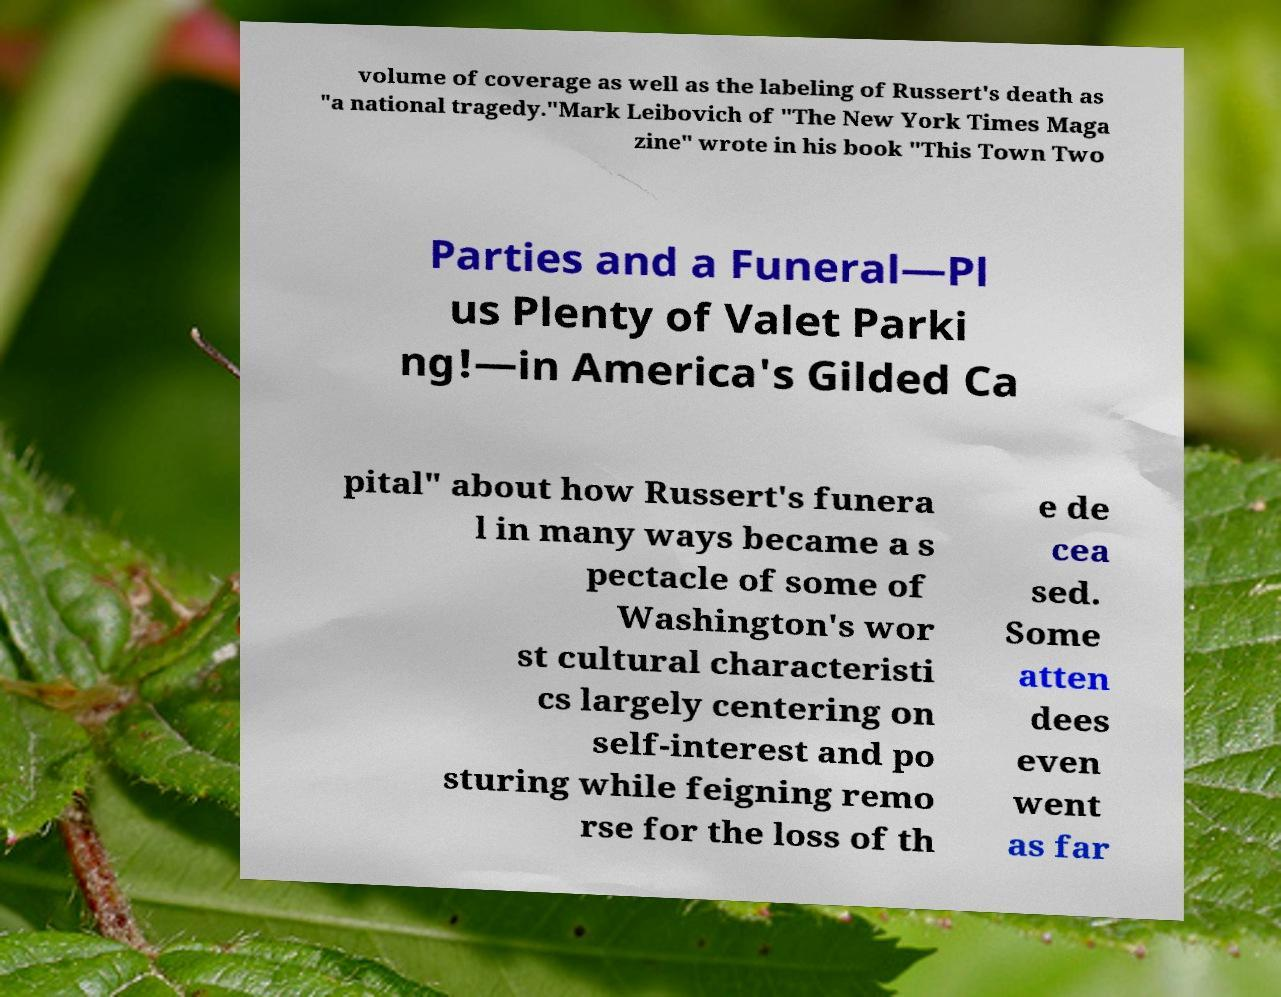Could you assist in decoding the text presented in this image and type it out clearly? volume of coverage as well as the labeling of Russert's death as "a national tragedy."Mark Leibovich of "The New York Times Maga zine" wrote in his book "This Town Two Parties and a Funeral—Pl us Plenty of Valet Parki ng!—in America's Gilded Ca pital" about how Russert's funera l in many ways became a s pectacle of some of Washington's wor st cultural characteristi cs largely centering on self-interest and po sturing while feigning remo rse for the loss of th e de cea sed. Some atten dees even went as far 